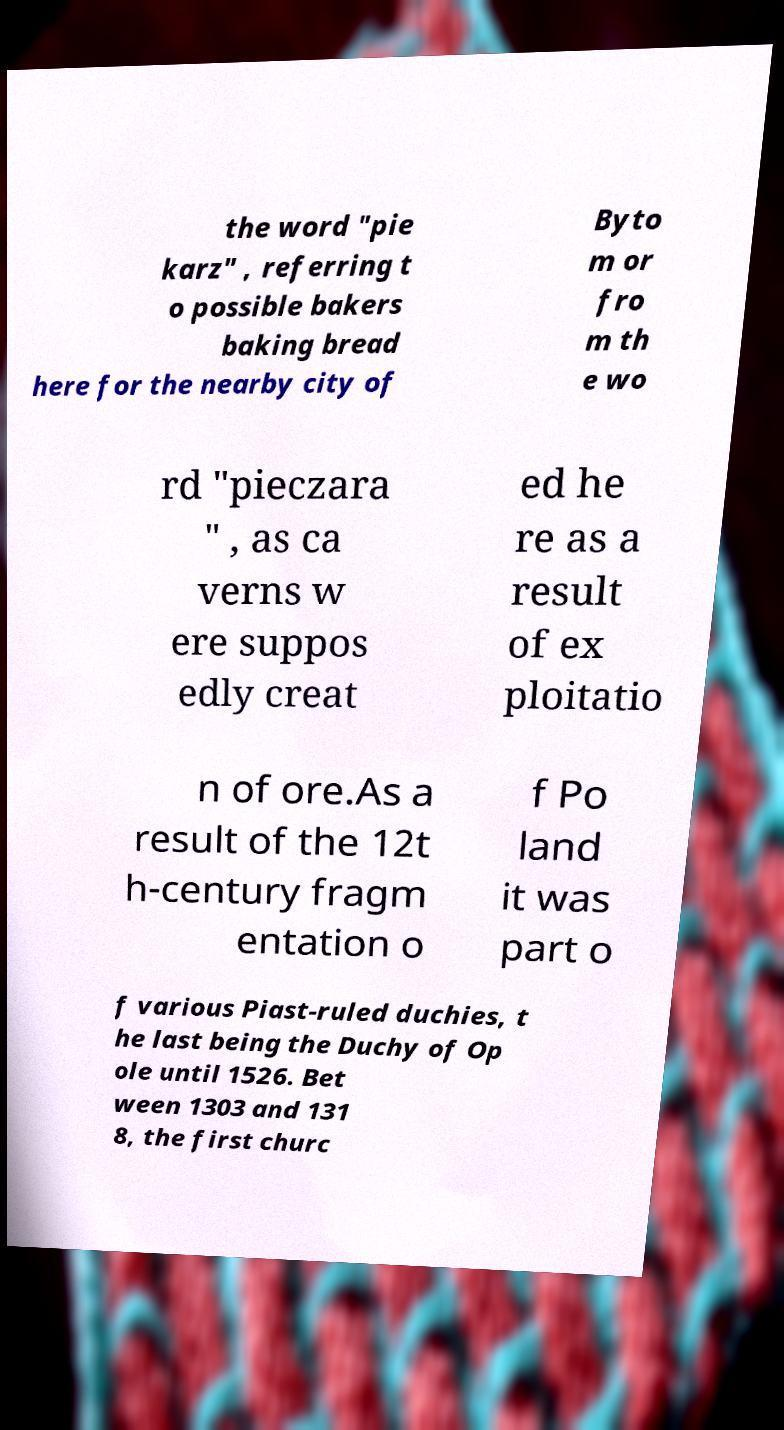Could you assist in decoding the text presented in this image and type it out clearly? the word "pie karz" , referring t o possible bakers baking bread here for the nearby city of Byto m or fro m th e wo rd "pieczara " , as ca verns w ere suppos edly creat ed he re as a result of ex ploitatio n of ore.As a result of the 12t h-century fragm entation o f Po land it was part o f various Piast-ruled duchies, t he last being the Duchy of Op ole until 1526. Bet ween 1303 and 131 8, the first churc 